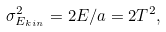<formula> <loc_0><loc_0><loc_500><loc_500>\sigma _ { E _ { k i n } } ^ { 2 } = 2 E / a = 2 T ^ { 2 } ,</formula> 